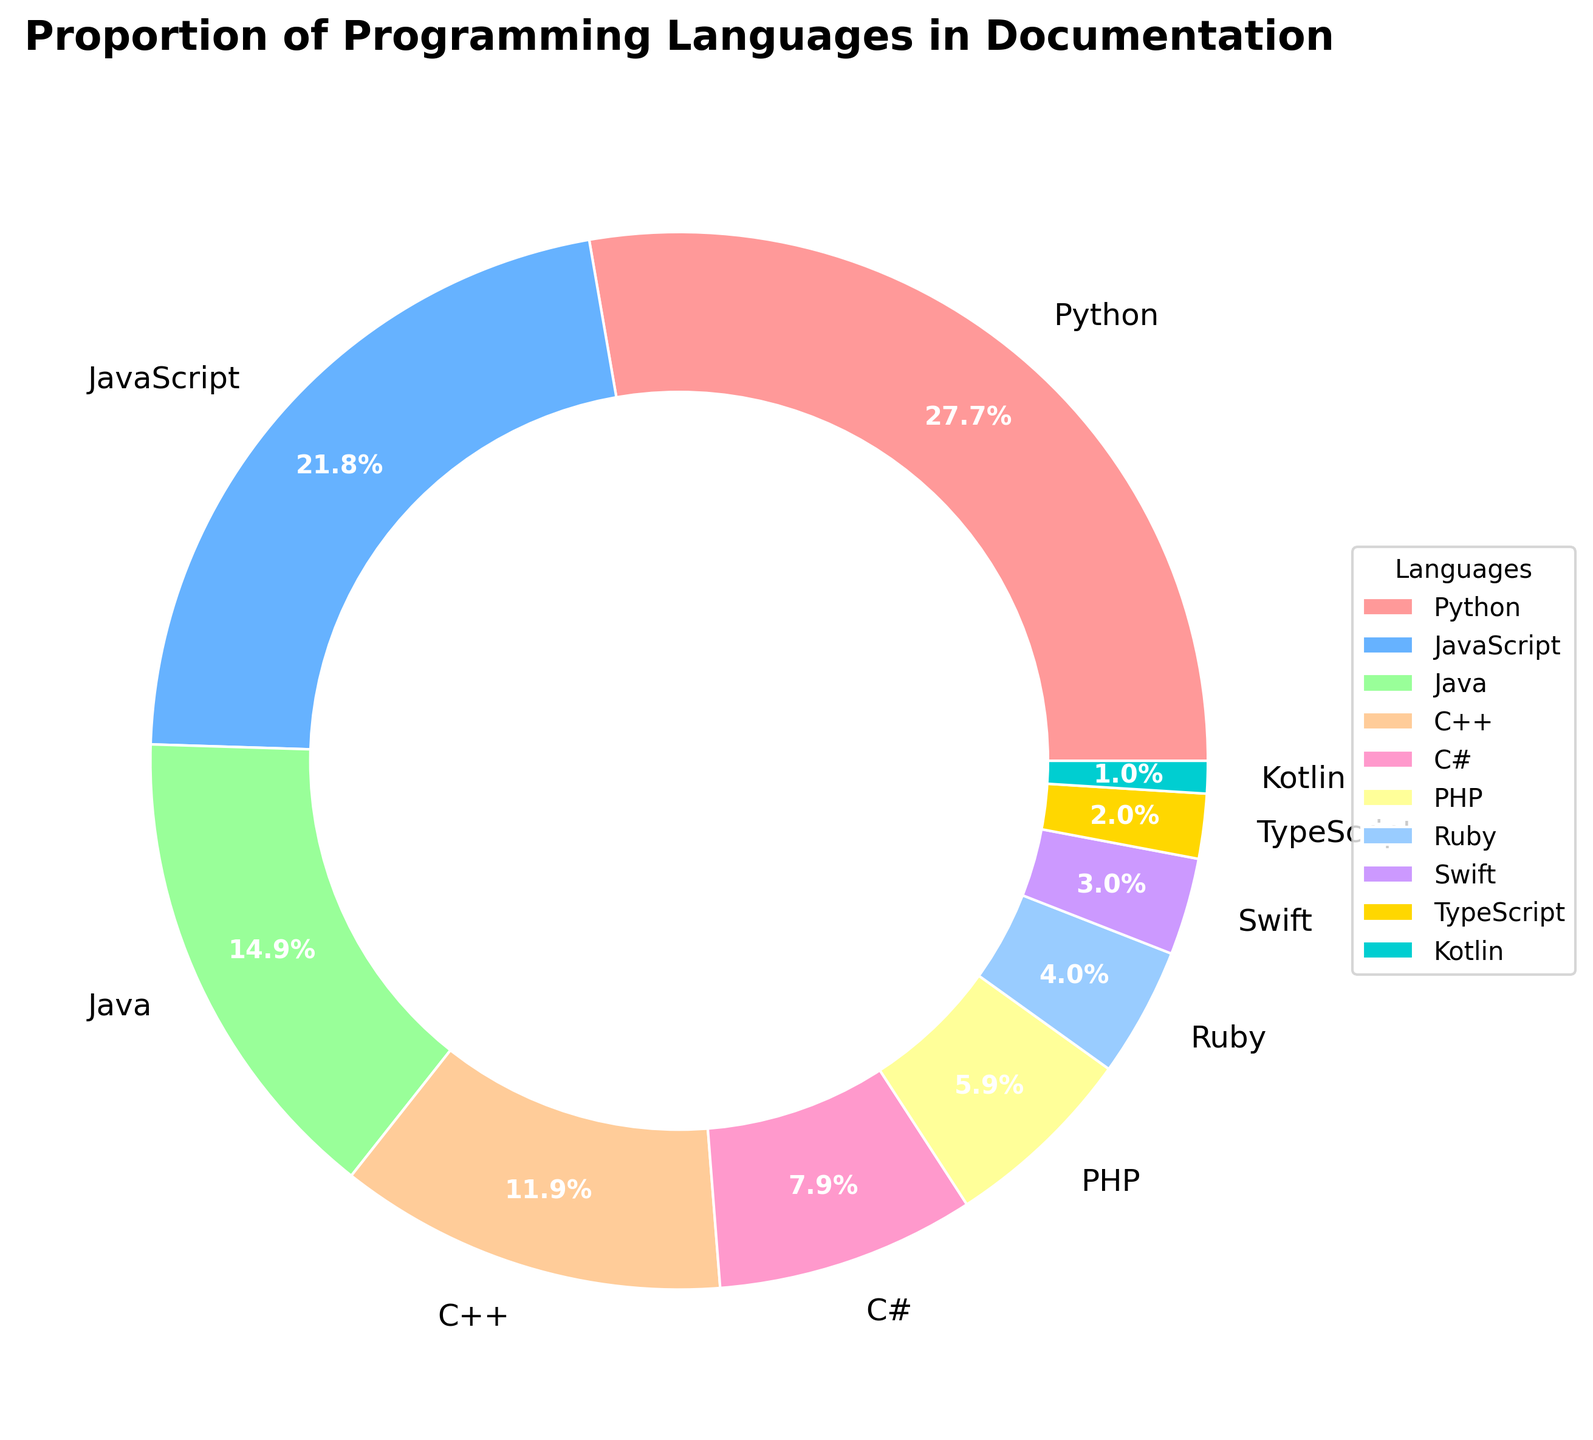What percentage of the documentation covers Python? The figure shows the proportion of different programming languages in the documentation as represented by the pie chart. Python has a section labeled with its percentage.
Answer: 28% Which language has a greater proportion in the documentation, Java or PHP? The pie chart displays the proportion of each language. By visually comparing the sizes of the slices, Java has a larger slice than PHP.
Answer: Java What is the combined proportion of C++ and C# in the documentation? Add the percentages of C++ and C# from the pie chart. C++ is 12%, and C# is 8%. Therefore, 12% + 8%.
Answer: 20% Which language has the smallest proportion in the documentation, and what is its percentage? Look at the smallest slice in the pie chart and find the corresponding label. According to the chart, Kotlin is the smallest with its percentage labeled.
Answer: Kotlin, 1% Is there more documentation for Ruby or TypeScript? Compare the slices for Ruby and TypeScript in the pie chart. Ruby's slice is larger.
Answer: Ruby What is the difference in proportion between the largest and smallest documented languages? Identify the largest (Python, 28%) and smallest (Kotlin, 1%) slices in the pie chart and subtract the smallest percentage from the largest. 28% - 1%.
Answer: 27% How does the proportion of Swift compare to C++? Visually compare the slices for Swift and C++ in the pie chart. C++ has a significantly larger proportion than Swift.
Answer: C++ is larger What is the total proportion of programming languages with more than 10% documentation coverage? Look at the pie chart for languages with slices larger than 10%: Python (28%), JavaScript (22%), and Java (15%). Sum these percentages: 28% + 22% + 15%.
Answer: 65% Which language in the documentation has approximately one-third the proportion of Python's coverage? Identify Python's percentage (28%) and divide by 3 to get approximately 9.3%. Look for the language close to this percentage in the pie chart. C# is close with 8%.
Answer: C# 